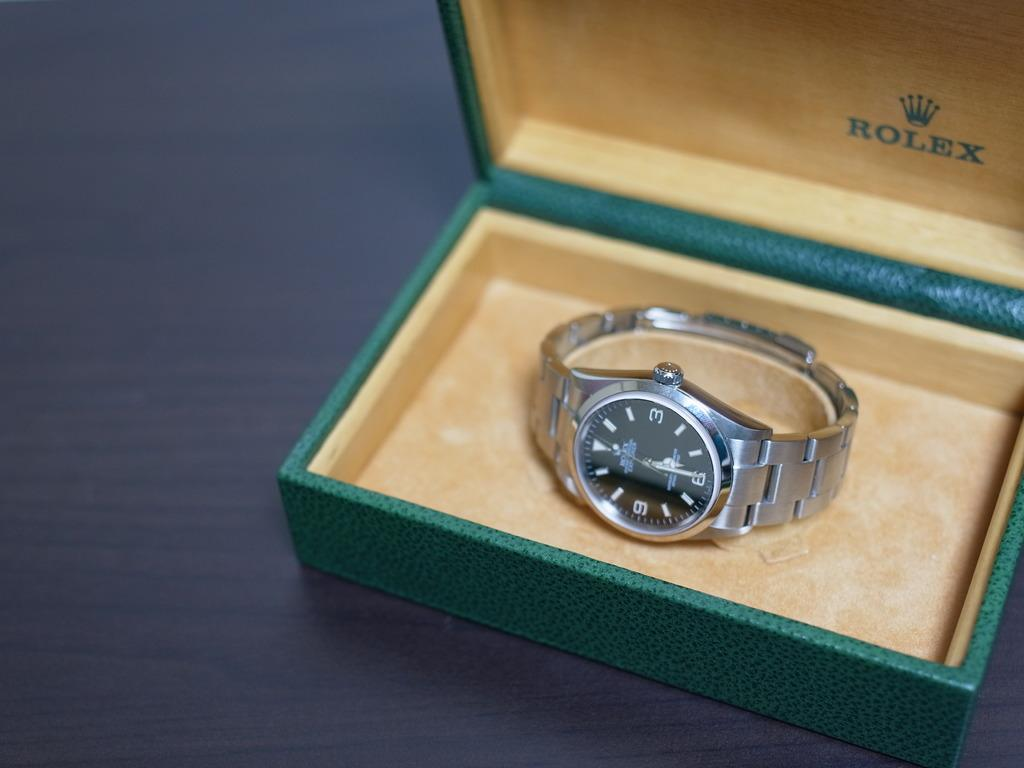<image>
Give a short and clear explanation of the subsequent image. a watch that has the word Rolex on the box 